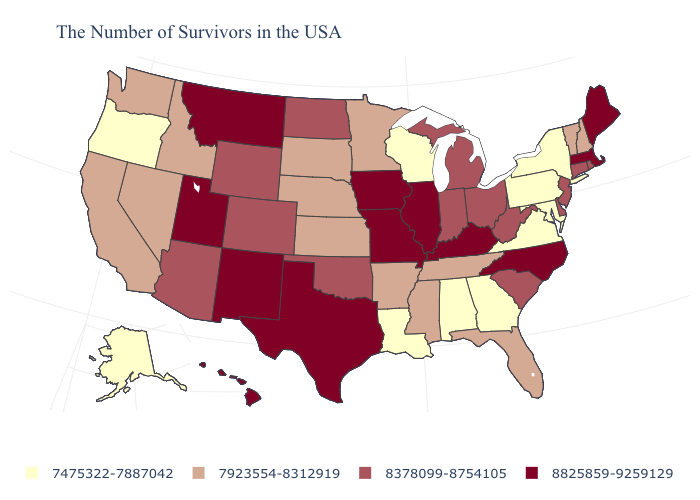Does Nevada have the same value as Arizona?
Quick response, please. No. What is the value of Connecticut?
Answer briefly. 8378099-8754105. What is the highest value in the MidWest ?
Short answer required. 8825859-9259129. What is the value of Wyoming?
Answer briefly. 8378099-8754105. Which states have the lowest value in the West?
Be succinct. Oregon, Alaska. Among the states that border New Hampshire , does Vermont have the highest value?
Write a very short answer. No. Does New Jersey have the same value as Montana?
Short answer required. No. What is the highest value in states that border Iowa?
Quick response, please. 8825859-9259129. What is the value of Montana?
Keep it brief. 8825859-9259129. Does Virginia have the lowest value in the South?
Be succinct. Yes. Which states have the lowest value in the USA?
Write a very short answer. New York, Maryland, Pennsylvania, Virginia, Georgia, Alabama, Wisconsin, Louisiana, Oregon, Alaska. Does Nebraska have the lowest value in the MidWest?
Short answer required. No. What is the value of Texas?
Write a very short answer. 8825859-9259129. What is the value of Nebraska?
Quick response, please. 7923554-8312919. Name the states that have a value in the range 7923554-8312919?
Keep it brief. New Hampshire, Vermont, Florida, Tennessee, Mississippi, Arkansas, Minnesota, Kansas, Nebraska, South Dakota, Idaho, Nevada, California, Washington. 